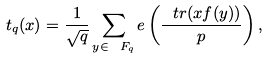<formula> <loc_0><loc_0><loc_500><loc_500>t _ { q } ( x ) = \frac { 1 } { \sqrt { q } } \sum _ { y \in \ F _ { q } } e \left ( \frac { \ t r ( x f ( y ) ) } { p } \right ) ,</formula> 